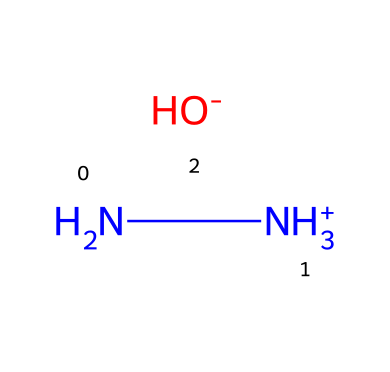What is the molecular formula of hydrazine hydrate? The chemical is represented as N[NH3+].[OH-], which indicates two nitrogen atoms (N) from the hydrazine part, along with six hydrogen atoms (H) and one oxygen atom (O) from the hydroxide, leading to the molecular formula N2H8O.
Answer: N2H8O How many hydrogen atoms are present in hydrazine hydrate? In the chemical structure N[NH3+].[OH-], the ammonia group contributes three hydrogen atoms for one nitrogen and another three for the second nitrogen, plus one from the hydroxide ion, totaling seven hydrogen atoms.
Answer: 8 What is the charge of the nitrogen in the hydrazine part? In the given structure, the nitrogen in N[NH3+] has a positive charge, which is indicated by the plus sign after NH3+.
Answer: positive What role does hydrazine hydrate play in water treatment? Hydrazine hydrate is a reducing agent that helps in the removal of dissolved oxygen in water systems, thereby preventing corrosion.
Answer: reducing agent What type of chemical is hydrazine hydrate classified as? The structure N[NH3+].[OH-] consists of nitrogen and hydrogen, indicating it is classified as an amine or more specifically, a hydrazine derivative, which is a type of organic compound.
Answer: amine How many nitrogen atoms are in hydrazine hydrate? The chemical N[NH3+].[OH-] indicates there are two nitrogen atoms present in the structure, one contributing to the hydrazine portion and the other as part of the amine group.
Answer: 2 What is the impact of hydrazine hydrate on recycling systems? Hydrazine hydrate reduces oxidation in recycling processes, enhancing the quality of recyclable materials by minimizing contaminant effects.
Answer: reduction of oxidation 